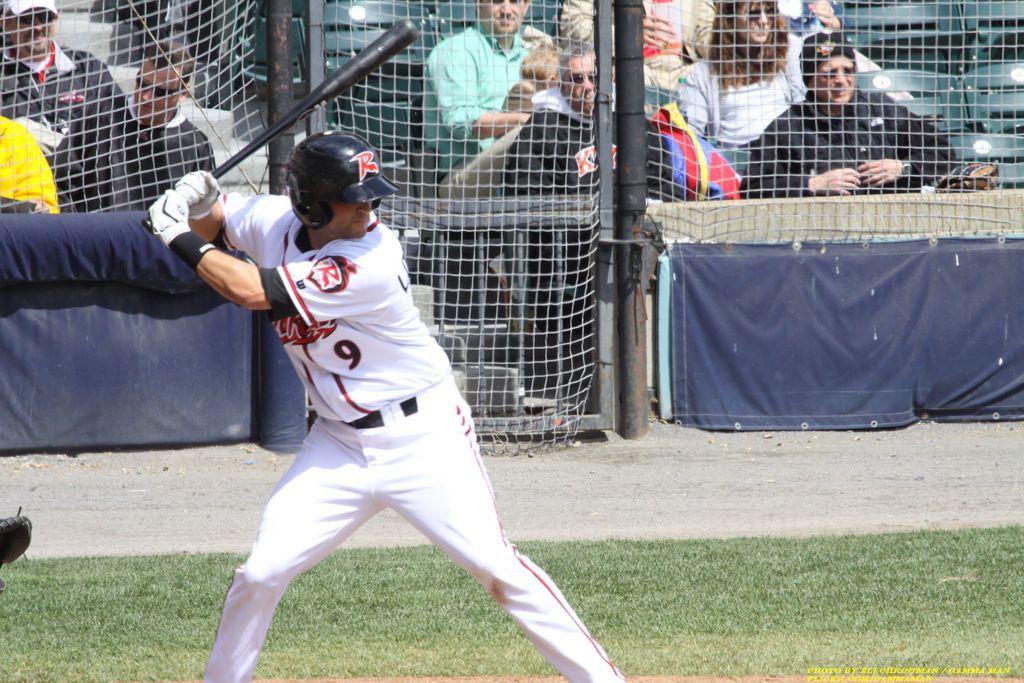What is the player's number?
Your answer should be compact. 9. What is number 9 doing?
Provide a short and direct response. Answering does not require reading text in the image. 